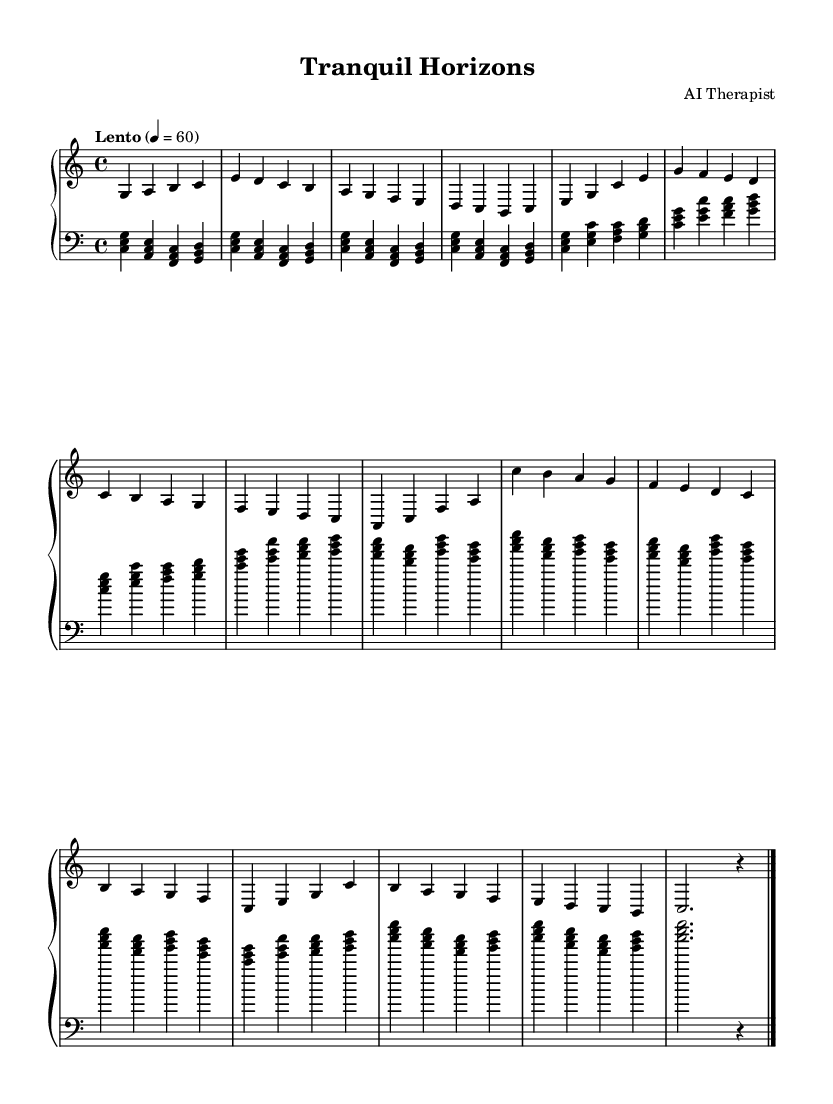What is the key signature of this music? The key signature is C major, which has no sharps or flats.
Answer: C major What is the time signature of this piece? The time signature indicates that there are four beats per measure, as shown by 4/4 written at the beginning.
Answer: 4/4 What is the tempo marking provided? The tempo marking specifies the speed of the piece as 'Lento', which means slow, set at 60 beats per minute.
Answer: Lento How many measures are there in the introduction section? By counting the measures written from the beginning to the end of the introduction, there are four measures.
Answer: 4 What musical form does this piece seem to follow? The piece has distinct sections labeled as Introduction, Section A, Section B, and Coda, indicating a binary or ternary structure typical in classical music.
Answer: Binary What is the dynamic marking for the right hand? The dynamic marking indicates the performance should be played with a 'dynamic up' for the right hand, guiding the player on how to express the music.
Answer: Dynamic up Which note is the highest pitch in the specified sections? The highest pitch found in the given sections is the note 'c'' in the Section B, which is indicated in the right hand part.
Answer: c' 